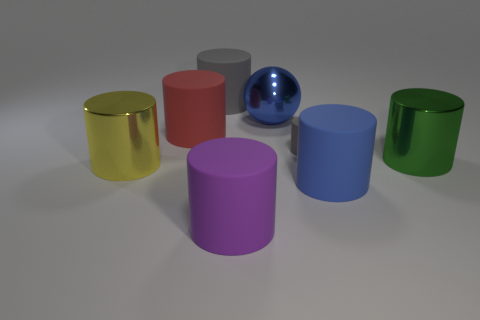Are there an equal number of matte cylinders that are in front of the green cylinder and big green shiny cylinders?
Provide a succinct answer. No. How big is the gray matte cylinder behind the large red cylinder?
Your answer should be very brief. Large. What number of other blue objects have the same shape as the blue metallic thing?
Keep it short and to the point. 0. There is a thing that is both to the left of the large gray matte cylinder and behind the big yellow cylinder; what material is it?
Your answer should be compact. Rubber. Are the big purple thing and the big yellow thing made of the same material?
Provide a succinct answer. No. What number of small cyan spheres are there?
Your answer should be compact. 0. The large metallic cylinder that is to the left of the gray cylinder in front of the gray rubber object that is behind the tiny gray thing is what color?
Offer a terse response. Yellow. What number of objects are behind the red rubber thing and to the left of the large blue metal ball?
Your answer should be very brief. 1. How many shiny objects are either tiny gray cylinders or blue cylinders?
Offer a terse response. 0. What is the material of the big blue thing behind the matte cylinder on the left side of the big gray rubber cylinder?
Offer a terse response. Metal. 